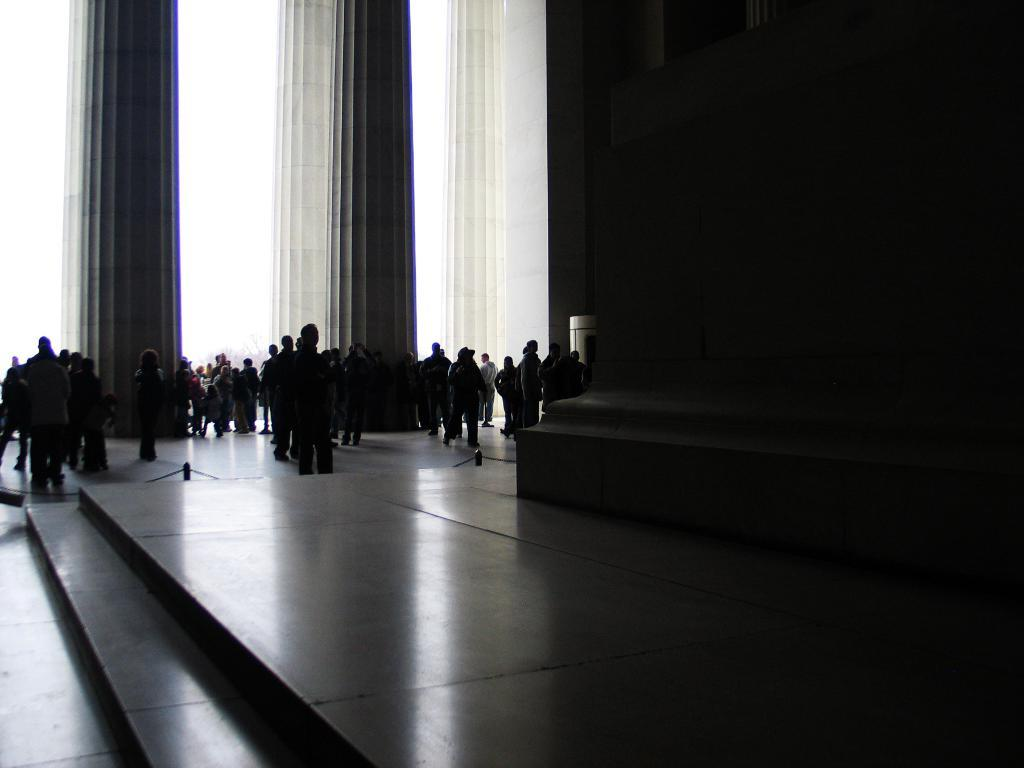What can be seen at the bottom of the image? The floor is visible at the bottom of the image. What is located on the right side of the image? There is a wall on the right side of the image. What are the people in the image doing? There are people standing on the floor on the left side of the image. What architectural features can be seen in the image? Pillars are present in the image. Where is the cactus located in the image? There is no cactus present in the image. What type of hall is visible in the image? There is no hall visible in the image. 